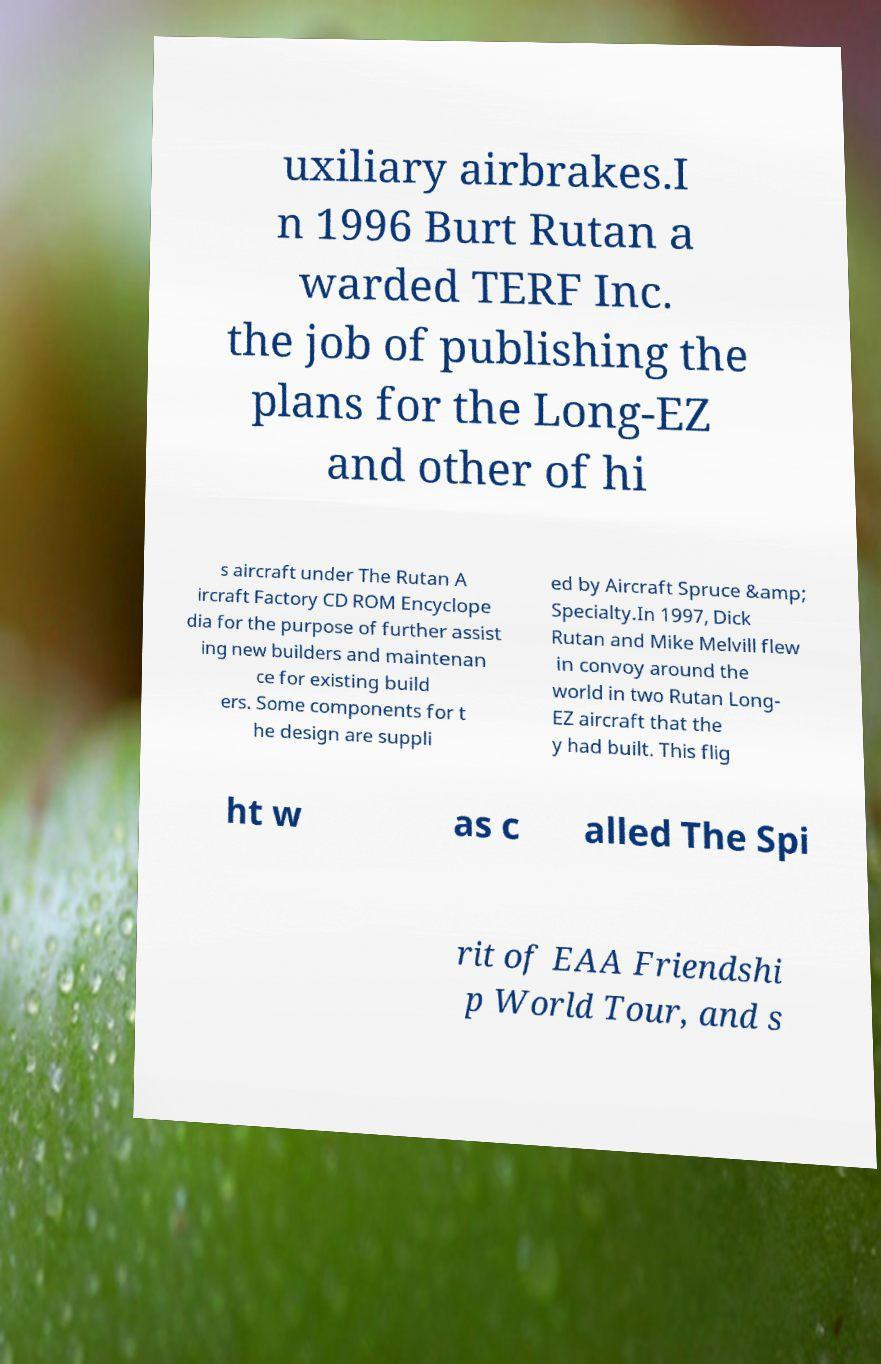Can you read and provide the text displayed in the image?This photo seems to have some interesting text. Can you extract and type it out for me? uxiliary airbrakes.I n 1996 Burt Rutan a warded TERF Inc. the job of publishing the plans for the Long-EZ and other of hi s aircraft under The Rutan A ircraft Factory CD ROM Encyclope dia for the purpose of further assist ing new builders and maintenan ce for existing build ers. Some components for t he design are suppli ed by Aircraft Spruce &amp; Specialty.In 1997, Dick Rutan and Mike Melvill flew in convoy around the world in two Rutan Long- EZ aircraft that the y had built. This flig ht w as c alled The Spi rit of EAA Friendshi p World Tour, and s 